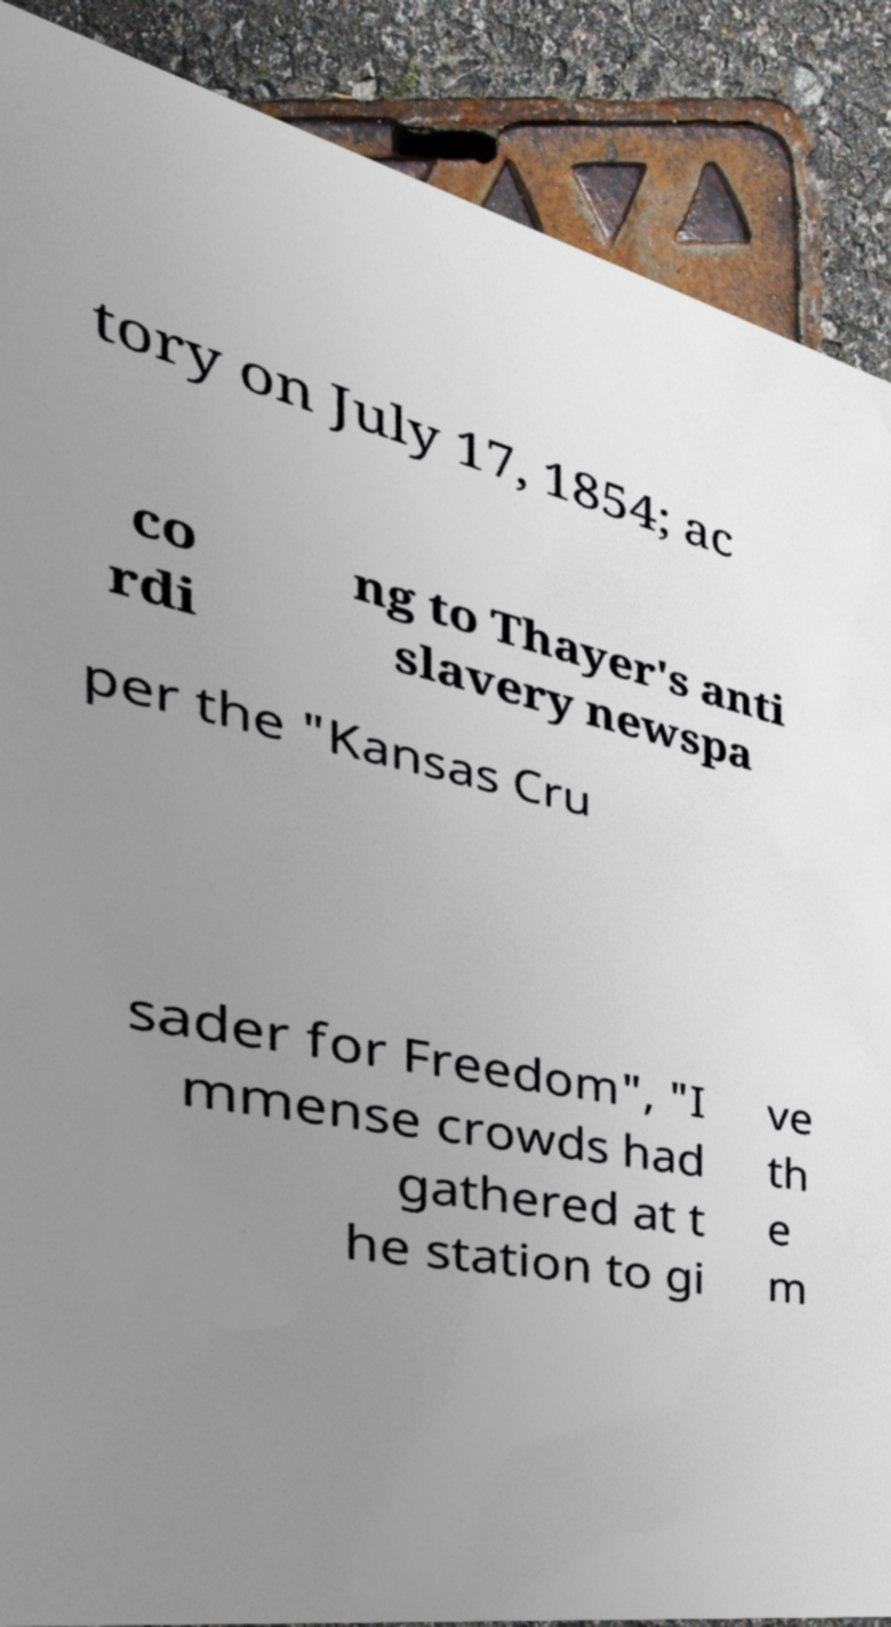Can you accurately transcribe the text from the provided image for me? tory on July 17, 1854; ac co rdi ng to Thayer's anti slavery newspa per the "Kansas Cru sader for Freedom", "I mmense crowds had gathered at t he station to gi ve th e m 